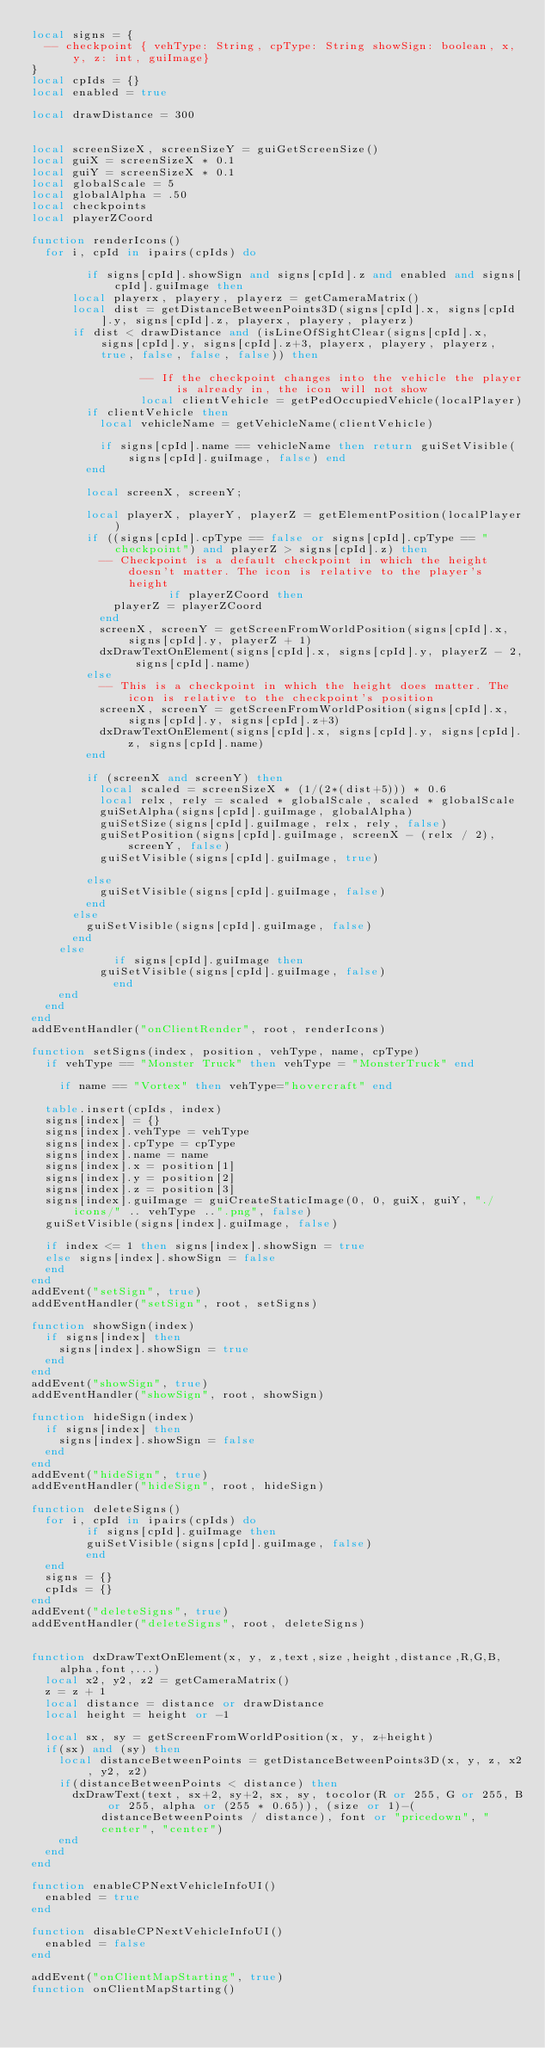Convert code to text. <code><loc_0><loc_0><loc_500><loc_500><_Lua_>local signs = {
	-- checkpoint { vehType: String, cpType: String showSign: boolean, x, y, z: int, guiImage}
}
local cpIds = {}
local enabled = true

local drawDistance = 300


local screenSizeX, screenSizeY = guiGetScreenSize()
local guiX = screenSizeX * 0.1
local guiY = screenSizeX * 0.1
local globalScale = 5
local globalAlpha = .50
local checkpoints
local playerZCoord

function renderIcons()
	for i, cpId in ipairs(cpIds) do
       
        if signs[cpId].showSign and signs[cpId].z and enabled and signs[cpId].guiImage then
			local playerx, playery, playerz = getCameraMatrix()
			local dist = getDistanceBetweenPoints3D(signs[cpId].x, signs[cpId].y, signs[cpId].z, playerx, playery, playerz)
			if dist < drawDistance and (isLineOfSightClear(signs[cpId].x, signs[cpId].y, signs[cpId].z+3, playerx, playery, playerz, true, false, false, false)) then
                
                -- If the checkpoint changes into the vehicle the player is already in, the icon will not show
                local clientVehicle = getPedOccupiedVehicle(localPlayer)
				if clientVehicle then 
					local vehicleName = getVehicleName(clientVehicle)
					
					if signs[cpId].name == vehicleName then return guiSetVisible(signs[cpId].guiImage, false) end
				end
                
				local screenX, screenY;
                
				local playerX, playerY, playerZ = getElementPosition(localPlayer)
				if ((signs[cpId].cpType == false or signs[cpId].cpType == "checkpoint") and playerZ > signs[cpId].z) then
					-- Checkpoint is a default checkpoint in which the height doesn't matter. The icon is relative to the player's height
                    if playerZCoord then
						playerZ = playerZCoord
					end
					screenX, screenY = getScreenFromWorldPosition(signs[cpId].x, signs[cpId].y, playerZ + 1)
					dxDrawTextOnElement(signs[cpId].x, signs[cpId].y, playerZ - 2, signs[cpId].name)
				else
					-- This is a checkpoint in which the height does matter. The icon is relative to the checkpoint's position
					screenX, screenY = getScreenFromWorldPosition(signs[cpId].x, signs[cpId].y, signs[cpId].z+3)
					dxDrawTextOnElement(signs[cpId].x, signs[cpId].y, signs[cpId].z, signs[cpId].name)
				end

				if (screenX and screenY) then
					local scaled = screenSizeX * (1/(2*(dist+5))) * 0.6
					local relx, rely = scaled * globalScale, scaled * globalScale
					guiSetAlpha(signs[cpId].guiImage, globalAlpha)
					guiSetSize(signs[cpId].guiImage, relx, rely, false)
					guiSetPosition(signs[cpId].guiImage, screenX - (relx / 2), screenY, false)
					guiSetVisible(signs[cpId].guiImage, true)

				else
					guiSetVisible(signs[cpId].guiImage, false)
				end
			else 
				guiSetVisible(signs[cpId].guiImage, false)
			end
		else
            if signs[cpId].guiImage then
			    guiSetVisible(signs[cpId].guiImage, false)
            end
		end
	end
end
addEventHandler("onClientRender", root, renderIcons)

function setSigns(index, position, vehType, name, cpType)
	if vehType == "Monster Truck" then vehType = "MonsterTruck" end
    
    if name == "Vortex" then vehType="hovercraft" end

	table.insert(cpIds, index)
	signs[index] = {}
	signs[index].vehType = vehType
	signs[index].cpType = cpType
	signs[index].name = name
	signs[index].x = position[1]
	signs[index].y = position[2]
	signs[index].z = position[3]
	signs[index].guiImage = guiCreateStaticImage(0, 0, guiX, guiY, "./icons/" .. vehType ..".png", false)
	guiSetVisible(signs[index].guiImage, false)

	if index <= 1 then signs[index].showSign = true
	else signs[index].showSign = false
	end
end
addEvent("setSign", true)
addEventHandler("setSign", root, setSigns)

function showSign(index)
	if signs[index] then
		signs[index].showSign = true
	end
end
addEvent("showSign", true)
addEventHandler("showSign", root, showSign)

function hideSign(index)
	if signs[index] then
		signs[index].showSign = false
	end
end
addEvent("hideSign", true)
addEventHandler("hideSign", root, hideSign)

function deleteSigns()
	for i, cpId in ipairs(cpIds) do
        if signs[cpId].guiImage then
		    guiSetVisible(signs[cpId].guiImage, false)
        end
	end
	signs = {}
	cpIds = {}
end
addEvent("deleteSigns", true)
addEventHandler("deleteSigns", root, deleteSigns)


function dxDrawTextOnElement(x, y, z,text,size,height,distance,R,G,B,alpha,font,...)
	local x2, y2, z2 = getCameraMatrix()
	z = z + 1
	local distance = distance or drawDistance
	local height = height or -1

	local sx, sy = getScreenFromWorldPosition(x, y, z+height)
	if(sx) and (sy) then
		local distanceBetweenPoints = getDistanceBetweenPoints3D(x, y, z, x2, y2, z2)
		if(distanceBetweenPoints < distance) then
			dxDrawText(text, sx+2, sy+2, sx, sy, tocolor(R or 255, G or 255, B or 255, alpha or (255 * 0.65)), (size or 1)-(distanceBetweenPoints / distance), font or "pricedown", "center", "center")
		end
	end
end

function enableCPNextVehicleInfoUI()
	enabled = true
end

function disableCPNextVehicleInfoUI()
	enabled = false
end

addEvent("onClientMapStarting", true)
function onClientMapStarting()</code> 